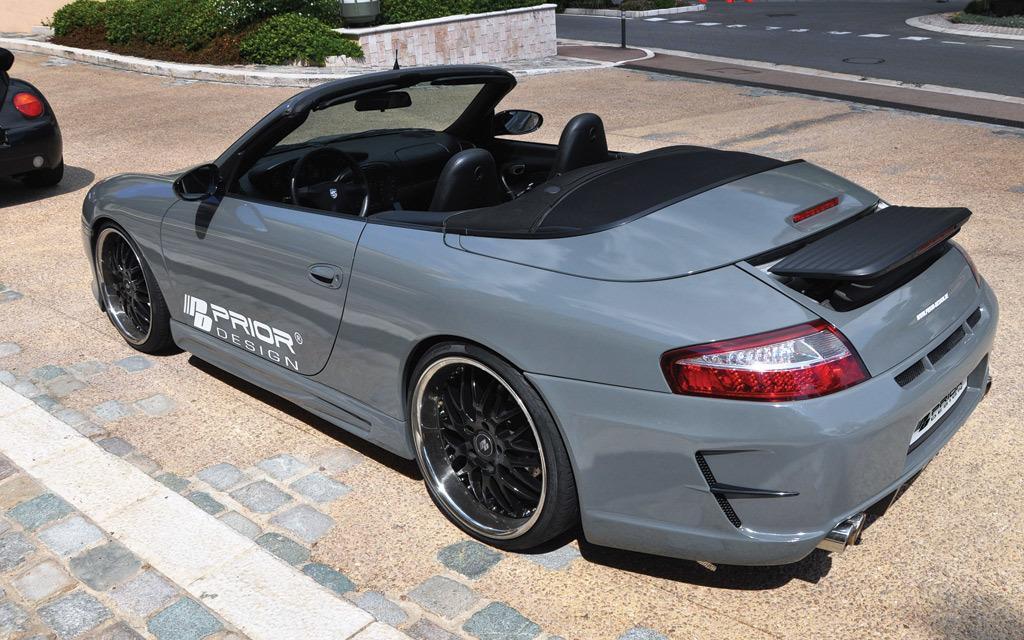Can you describe this image briefly? In the picture we can see a car which is light blue in color, and which is placed on the path, in the background we can see plants, road and another car before this car, on the car we can see the name prior design. 